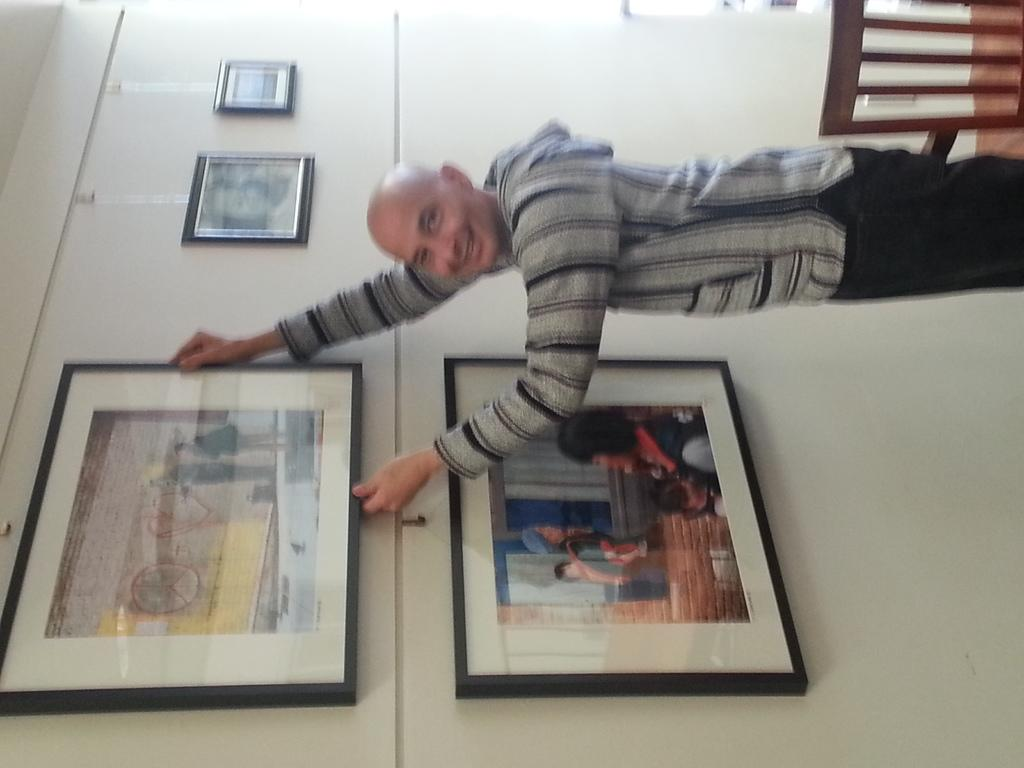What is the main subject of the image? There is a man standing in the image. What can be seen in the background of the image? There is a wall in the image. What is hanging on the wall? There are frames on the wall. Where is the chair located in the image? There is a chair in the top right corner of the image. What type of insurance policy is the man discussing in the image? There is no indication in the image that the man is discussing any insurance policy. Can you see any snakes in the image? There are no snakes present in the image. 